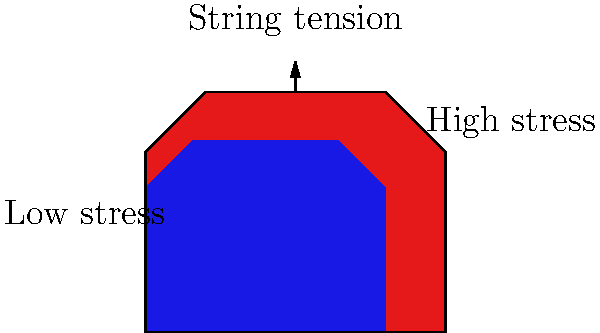In a punk rock guitar, the body experiences stress due to string tension. Which part of the guitar body typically experiences the highest stress, and why is this important for the instrument's sound? To understand the stress distribution in a guitar body, let's break it down:

1. String tension: The strings of a guitar are under high tension, which is transferred to the guitar body.

2. Stress concentration: The area where the strings attach to the body (usually the bridge) experiences the highest stress concentration.

3. Stress distribution: The stress spreads out from the high-stress area (red in the diagram) to lower-stress areas (blue in the diagram).

4. Importance for sound:
   a) High-stress areas vibrate less, affecting the guitar's sustain.
   b) The way stress is distributed influences the overall resonance of the instrument.

5. Material considerations: Different woods and materials respond differently to stress, affecting tone.

6. Punk rock context: The high-energy playing style in punk often puts more stress on the instrument, making stress distribution even more critical.

The highest stress area (near the bridge) is crucial because it affects the guitar's tone, sustain, and overall durability, which are essential for the raw, energetic sound characteristic of punk rock.
Answer: Bridge area; affects tone and sustain 